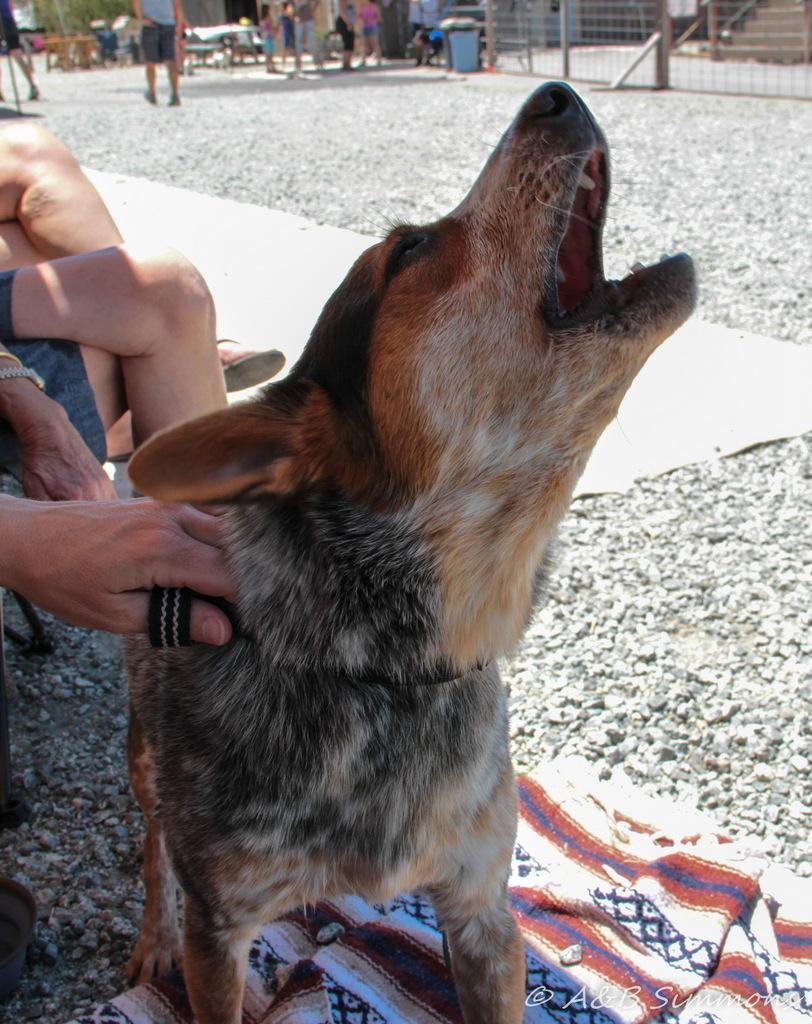Describe this image in one or two sentences. In this image, I can see a dog standing. On the left side of the image, there are two people sitting and a person's hand holding a dog belt. At the bottom of the image, I can see a cloth on the rocks and there is the watermark. In the background, I can see few people standing. There is a dustbin, fence and few other objects. 